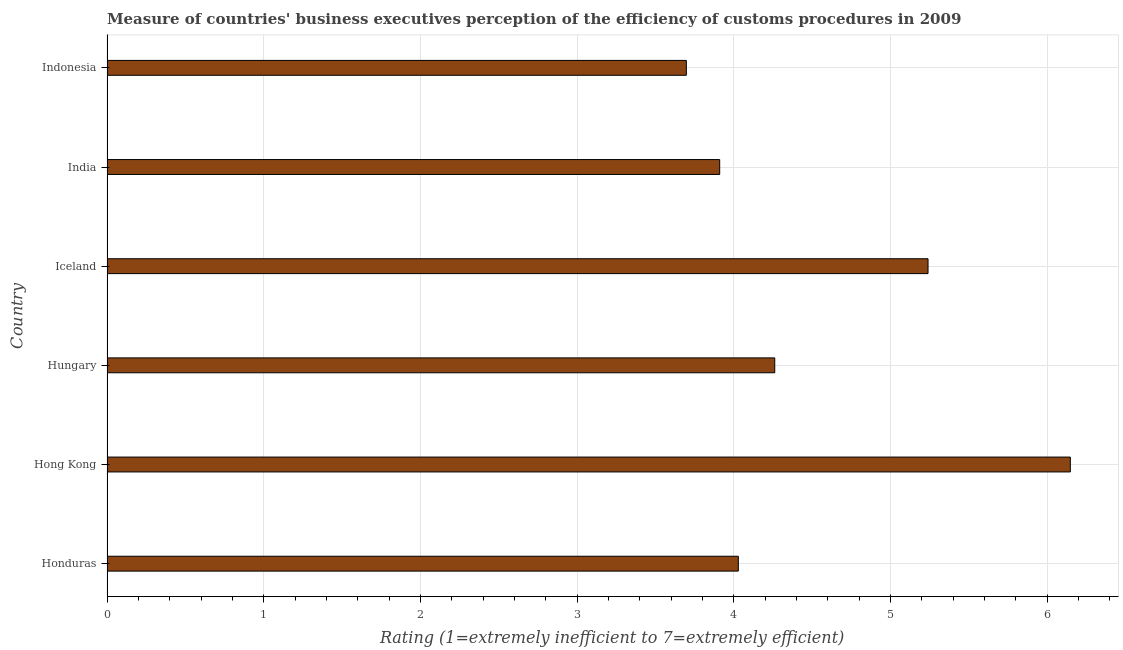What is the title of the graph?
Offer a very short reply. Measure of countries' business executives perception of the efficiency of customs procedures in 2009. What is the label or title of the X-axis?
Offer a terse response. Rating (1=extremely inefficient to 7=extremely efficient). What is the rating measuring burden of customs procedure in Indonesia?
Your answer should be very brief. 3.7. Across all countries, what is the maximum rating measuring burden of customs procedure?
Offer a terse response. 6.15. Across all countries, what is the minimum rating measuring burden of customs procedure?
Provide a succinct answer. 3.7. In which country was the rating measuring burden of customs procedure maximum?
Give a very brief answer. Hong Kong. In which country was the rating measuring burden of customs procedure minimum?
Offer a terse response. Indonesia. What is the sum of the rating measuring burden of customs procedure?
Your response must be concise. 27.29. What is the difference between the rating measuring burden of customs procedure in Honduras and Iceland?
Make the answer very short. -1.21. What is the average rating measuring burden of customs procedure per country?
Provide a succinct answer. 4.55. What is the median rating measuring burden of customs procedure?
Give a very brief answer. 4.15. In how many countries, is the rating measuring burden of customs procedure greater than 1.2 ?
Provide a succinct answer. 6. Is the rating measuring burden of customs procedure in Hungary less than that in India?
Offer a very short reply. No. Is the difference between the rating measuring burden of customs procedure in Honduras and Hungary greater than the difference between any two countries?
Keep it short and to the point. No. What is the difference between the highest and the second highest rating measuring burden of customs procedure?
Make the answer very short. 0.91. Is the sum of the rating measuring burden of customs procedure in Hungary and Iceland greater than the maximum rating measuring burden of customs procedure across all countries?
Provide a short and direct response. Yes. What is the difference between the highest and the lowest rating measuring burden of customs procedure?
Your response must be concise. 2.45. Are all the bars in the graph horizontal?
Give a very brief answer. Yes. What is the difference between two consecutive major ticks on the X-axis?
Ensure brevity in your answer.  1. Are the values on the major ticks of X-axis written in scientific E-notation?
Keep it short and to the point. No. What is the Rating (1=extremely inefficient to 7=extremely efficient) in Honduras?
Ensure brevity in your answer.  4.03. What is the Rating (1=extremely inefficient to 7=extremely efficient) in Hong Kong?
Make the answer very short. 6.15. What is the Rating (1=extremely inefficient to 7=extremely efficient) of Hungary?
Keep it short and to the point. 4.26. What is the Rating (1=extremely inefficient to 7=extremely efficient) of Iceland?
Your answer should be very brief. 5.24. What is the Rating (1=extremely inefficient to 7=extremely efficient) of India?
Offer a very short reply. 3.91. What is the Rating (1=extremely inefficient to 7=extremely efficient) of Indonesia?
Your answer should be compact. 3.7. What is the difference between the Rating (1=extremely inefficient to 7=extremely efficient) in Honduras and Hong Kong?
Your answer should be very brief. -2.12. What is the difference between the Rating (1=extremely inefficient to 7=extremely efficient) in Honduras and Hungary?
Make the answer very short. -0.23. What is the difference between the Rating (1=extremely inefficient to 7=extremely efficient) in Honduras and Iceland?
Offer a terse response. -1.21. What is the difference between the Rating (1=extremely inefficient to 7=extremely efficient) in Honduras and India?
Offer a terse response. 0.12. What is the difference between the Rating (1=extremely inefficient to 7=extremely efficient) in Honduras and Indonesia?
Keep it short and to the point. 0.33. What is the difference between the Rating (1=extremely inefficient to 7=extremely efficient) in Hong Kong and Hungary?
Offer a very short reply. 1.89. What is the difference between the Rating (1=extremely inefficient to 7=extremely efficient) in Hong Kong and Iceland?
Your answer should be very brief. 0.91. What is the difference between the Rating (1=extremely inefficient to 7=extremely efficient) in Hong Kong and India?
Give a very brief answer. 2.24. What is the difference between the Rating (1=extremely inefficient to 7=extremely efficient) in Hong Kong and Indonesia?
Give a very brief answer. 2.45. What is the difference between the Rating (1=extremely inefficient to 7=extremely efficient) in Hungary and Iceland?
Your answer should be compact. -0.98. What is the difference between the Rating (1=extremely inefficient to 7=extremely efficient) in Hungary and India?
Provide a short and direct response. 0.35. What is the difference between the Rating (1=extremely inefficient to 7=extremely efficient) in Hungary and Indonesia?
Your answer should be compact. 0.56. What is the difference between the Rating (1=extremely inefficient to 7=extremely efficient) in Iceland and India?
Make the answer very short. 1.33. What is the difference between the Rating (1=extremely inefficient to 7=extremely efficient) in Iceland and Indonesia?
Give a very brief answer. 1.54. What is the difference between the Rating (1=extremely inefficient to 7=extremely efficient) in India and Indonesia?
Offer a terse response. 0.21. What is the ratio of the Rating (1=extremely inefficient to 7=extremely efficient) in Honduras to that in Hong Kong?
Ensure brevity in your answer.  0.66. What is the ratio of the Rating (1=extremely inefficient to 7=extremely efficient) in Honduras to that in Hungary?
Give a very brief answer. 0.94. What is the ratio of the Rating (1=extremely inefficient to 7=extremely efficient) in Honduras to that in Iceland?
Make the answer very short. 0.77. What is the ratio of the Rating (1=extremely inefficient to 7=extremely efficient) in Honduras to that in India?
Your answer should be very brief. 1.03. What is the ratio of the Rating (1=extremely inefficient to 7=extremely efficient) in Honduras to that in Indonesia?
Provide a succinct answer. 1.09. What is the ratio of the Rating (1=extremely inefficient to 7=extremely efficient) in Hong Kong to that in Hungary?
Your answer should be compact. 1.44. What is the ratio of the Rating (1=extremely inefficient to 7=extremely efficient) in Hong Kong to that in Iceland?
Offer a very short reply. 1.17. What is the ratio of the Rating (1=extremely inefficient to 7=extremely efficient) in Hong Kong to that in India?
Your answer should be very brief. 1.57. What is the ratio of the Rating (1=extremely inefficient to 7=extremely efficient) in Hong Kong to that in Indonesia?
Ensure brevity in your answer.  1.66. What is the ratio of the Rating (1=extremely inefficient to 7=extremely efficient) in Hungary to that in Iceland?
Give a very brief answer. 0.81. What is the ratio of the Rating (1=extremely inefficient to 7=extremely efficient) in Hungary to that in India?
Provide a short and direct response. 1.09. What is the ratio of the Rating (1=extremely inefficient to 7=extremely efficient) in Hungary to that in Indonesia?
Give a very brief answer. 1.15. What is the ratio of the Rating (1=extremely inefficient to 7=extremely efficient) in Iceland to that in India?
Ensure brevity in your answer.  1.34. What is the ratio of the Rating (1=extremely inefficient to 7=extremely efficient) in Iceland to that in Indonesia?
Provide a succinct answer. 1.42. What is the ratio of the Rating (1=extremely inefficient to 7=extremely efficient) in India to that in Indonesia?
Offer a terse response. 1.06. 